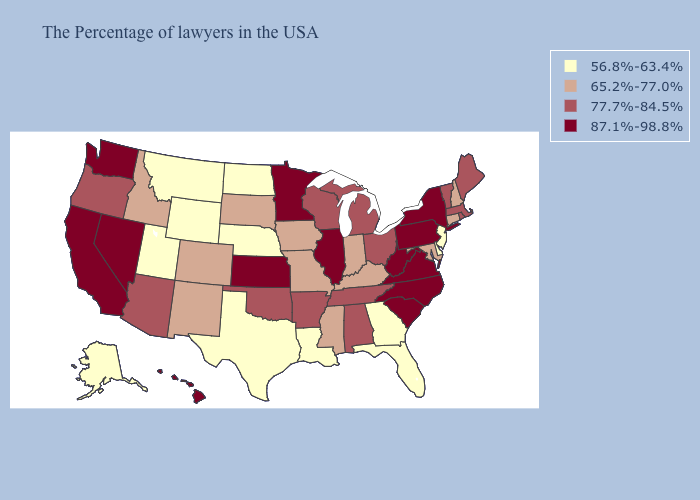What is the highest value in states that border California?
Concise answer only. 87.1%-98.8%. What is the value of New Jersey?
Keep it brief. 56.8%-63.4%. What is the lowest value in states that border South Dakota?
Answer briefly. 56.8%-63.4%. Among the states that border North Dakota , which have the highest value?
Give a very brief answer. Minnesota. Which states have the lowest value in the Northeast?
Concise answer only. New Jersey. Among the states that border Illinois , does Indiana have the lowest value?
Be succinct. Yes. Is the legend a continuous bar?
Be succinct. No. Name the states that have a value in the range 65.2%-77.0%?
Be succinct. New Hampshire, Connecticut, Maryland, Kentucky, Indiana, Mississippi, Missouri, Iowa, South Dakota, Colorado, New Mexico, Idaho. What is the lowest value in the South?
Short answer required. 56.8%-63.4%. What is the highest value in the USA?
Give a very brief answer. 87.1%-98.8%. What is the value of Idaho?
Quick response, please. 65.2%-77.0%. What is the value of Arizona?
Give a very brief answer. 77.7%-84.5%. Does Utah have the lowest value in the West?
Give a very brief answer. Yes. How many symbols are there in the legend?
Concise answer only. 4. What is the lowest value in the USA?
Concise answer only. 56.8%-63.4%. 